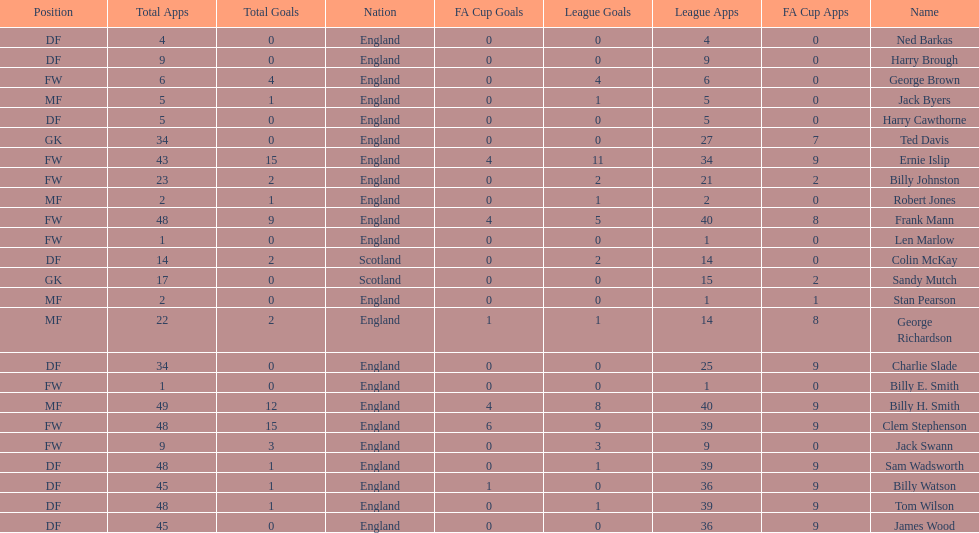Average number of goals scored by players from scotland 1. 